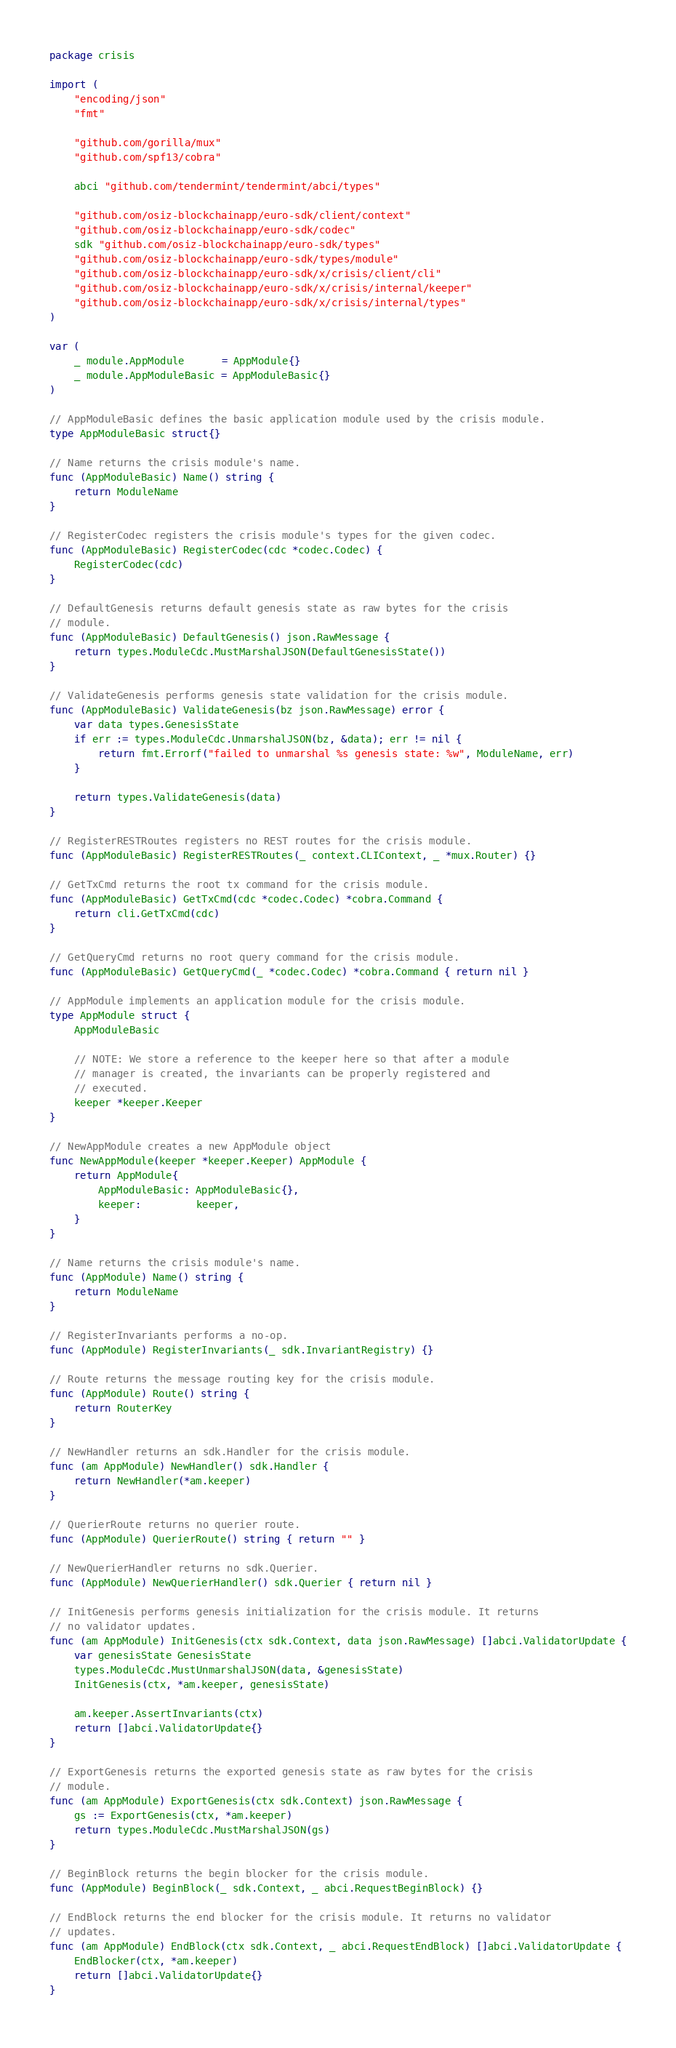<code> <loc_0><loc_0><loc_500><loc_500><_Go_>package crisis

import (
	"encoding/json"
	"fmt"

	"github.com/gorilla/mux"
	"github.com/spf13/cobra"

	abci "github.com/tendermint/tendermint/abci/types"

	"github.com/osiz-blockchainapp/euro-sdk/client/context"
	"github.com/osiz-blockchainapp/euro-sdk/codec"
	sdk "github.com/osiz-blockchainapp/euro-sdk/types"
	"github.com/osiz-blockchainapp/euro-sdk/types/module"
	"github.com/osiz-blockchainapp/euro-sdk/x/crisis/client/cli"
	"github.com/osiz-blockchainapp/euro-sdk/x/crisis/internal/keeper"
	"github.com/osiz-blockchainapp/euro-sdk/x/crisis/internal/types"
)

var (
	_ module.AppModule      = AppModule{}
	_ module.AppModuleBasic = AppModuleBasic{}
)

// AppModuleBasic defines the basic application module used by the crisis module.
type AppModuleBasic struct{}

// Name returns the crisis module's name.
func (AppModuleBasic) Name() string {
	return ModuleName
}

// RegisterCodec registers the crisis module's types for the given codec.
func (AppModuleBasic) RegisterCodec(cdc *codec.Codec) {
	RegisterCodec(cdc)
}

// DefaultGenesis returns default genesis state as raw bytes for the crisis
// module.
func (AppModuleBasic) DefaultGenesis() json.RawMessage {
	return types.ModuleCdc.MustMarshalJSON(DefaultGenesisState())
}

// ValidateGenesis performs genesis state validation for the crisis module.
func (AppModuleBasic) ValidateGenesis(bz json.RawMessage) error {
	var data types.GenesisState
	if err := types.ModuleCdc.UnmarshalJSON(bz, &data); err != nil {
		return fmt.Errorf("failed to unmarshal %s genesis state: %w", ModuleName, err)
	}

	return types.ValidateGenesis(data)
}

// RegisterRESTRoutes registers no REST routes for the crisis module.
func (AppModuleBasic) RegisterRESTRoutes(_ context.CLIContext, _ *mux.Router) {}

// GetTxCmd returns the root tx command for the crisis module.
func (AppModuleBasic) GetTxCmd(cdc *codec.Codec) *cobra.Command {
	return cli.GetTxCmd(cdc)
}

// GetQueryCmd returns no root query command for the crisis module.
func (AppModuleBasic) GetQueryCmd(_ *codec.Codec) *cobra.Command { return nil }

// AppModule implements an application module for the crisis module.
type AppModule struct {
	AppModuleBasic

	// NOTE: We store a reference to the keeper here so that after a module
	// manager is created, the invariants can be properly registered and
	// executed.
	keeper *keeper.Keeper
}

// NewAppModule creates a new AppModule object
func NewAppModule(keeper *keeper.Keeper) AppModule {
	return AppModule{
		AppModuleBasic: AppModuleBasic{},
		keeper:         keeper,
	}
}

// Name returns the crisis module's name.
func (AppModule) Name() string {
	return ModuleName
}

// RegisterInvariants performs a no-op.
func (AppModule) RegisterInvariants(_ sdk.InvariantRegistry) {}

// Route returns the message routing key for the crisis module.
func (AppModule) Route() string {
	return RouterKey
}

// NewHandler returns an sdk.Handler for the crisis module.
func (am AppModule) NewHandler() sdk.Handler {
	return NewHandler(*am.keeper)
}

// QuerierRoute returns no querier route.
func (AppModule) QuerierRoute() string { return "" }

// NewQuerierHandler returns no sdk.Querier.
func (AppModule) NewQuerierHandler() sdk.Querier { return nil }

// InitGenesis performs genesis initialization for the crisis module. It returns
// no validator updates.
func (am AppModule) InitGenesis(ctx sdk.Context, data json.RawMessage) []abci.ValidatorUpdate {
	var genesisState GenesisState
	types.ModuleCdc.MustUnmarshalJSON(data, &genesisState)
	InitGenesis(ctx, *am.keeper, genesisState)

	am.keeper.AssertInvariants(ctx)
	return []abci.ValidatorUpdate{}
}

// ExportGenesis returns the exported genesis state as raw bytes for the crisis
// module.
func (am AppModule) ExportGenesis(ctx sdk.Context) json.RawMessage {
	gs := ExportGenesis(ctx, *am.keeper)
	return types.ModuleCdc.MustMarshalJSON(gs)
}

// BeginBlock returns the begin blocker for the crisis module.
func (AppModule) BeginBlock(_ sdk.Context, _ abci.RequestBeginBlock) {}

// EndBlock returns the end blocker for the crisis module. It returns no validator
// updates.
func (am AppModule) EndBlock(ctx sdk.Context, _ abci.RequestEndBlock) []abci.ValidatorUpdate {
	EndBlocker(ctx, *am.keeper)
	return []abci.ValidatorUpdate{}
}
</code> 